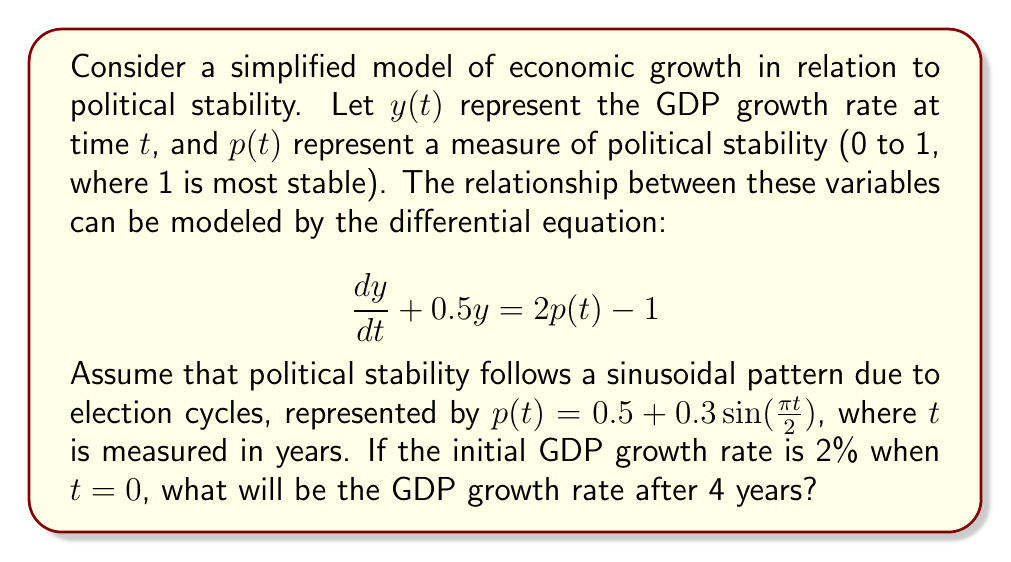Teach me how to tackle this problem. To solve this problem, we need to follow these steps:

1) First, we need to solve the non-homogeneous differential equation:

   $$\frac{dy}{dt} + 0.5y = 2p(t) - 1$$

2) Substituting $p(t) = 0.5 + 0.3\sin(\frac{\pi t}{2})$, we get:

   $$\frac{dy}{dt} + 0.5y = 2(0.5 + 0.3\sin(\frac{\pi t}{2})) - 1 = 0.6\sin(\frac{\pi t}{2})$$

3) The general solution to this equation is the sum of the complementary function (solution to the homogeneous equation) and a particular integral:

   $y = y_c + y_p$

4) The complementary function is:

   $y_c = Ae^{-0.5t}$

5) For the particular integral, we can use the method of undetermined coefficients. Let:

   $y_p = a\sin(\frac{\pi t}{2}) + b\cos(\frac{\pi t}{2})$

6) Substituting this into the original equation and solving for $a$ and $b$, we get:

   $y_p = 0.6\sin(\frac{\pi t}{2}) - 0.3\pi\cos(\frac{\pi t}{2})$

7) Therefore, the general solution is:

   $y = Ae^{-0.5t} + 0.6\sin(\frac{\pi t}{2}) - 0.3\pi\cos(\frac{\pi t}{2})$

8) Using the initial condition $y(0) = 0.02$, we can find $A$:

   $0.02 = A - 0.3\pi$
   $A = 0.02 + 0.3\pi$

9) So the particular solution is:

   $y = (0.02 + 0.3\pi)e^{-0.5t} + 0.6\sin(\frac{\pi t}{2}) - 0.3\pi\cos(\frac{\pi t}{2})$

10) To find the GDP growth rate after 4 years, we substitute $t = 4$:

    $y(4) = (0.02 + 0.3\pi)e^{-2} + 0.6\sin(2\pi) - 0.3\pi\cos(2\pi)$

11) Calculating this value:

    $y(4) \approx 0.0196$ or $1.96\%$
Answer: The GDP growth rate after 4 years will be approximately 1.96%. 